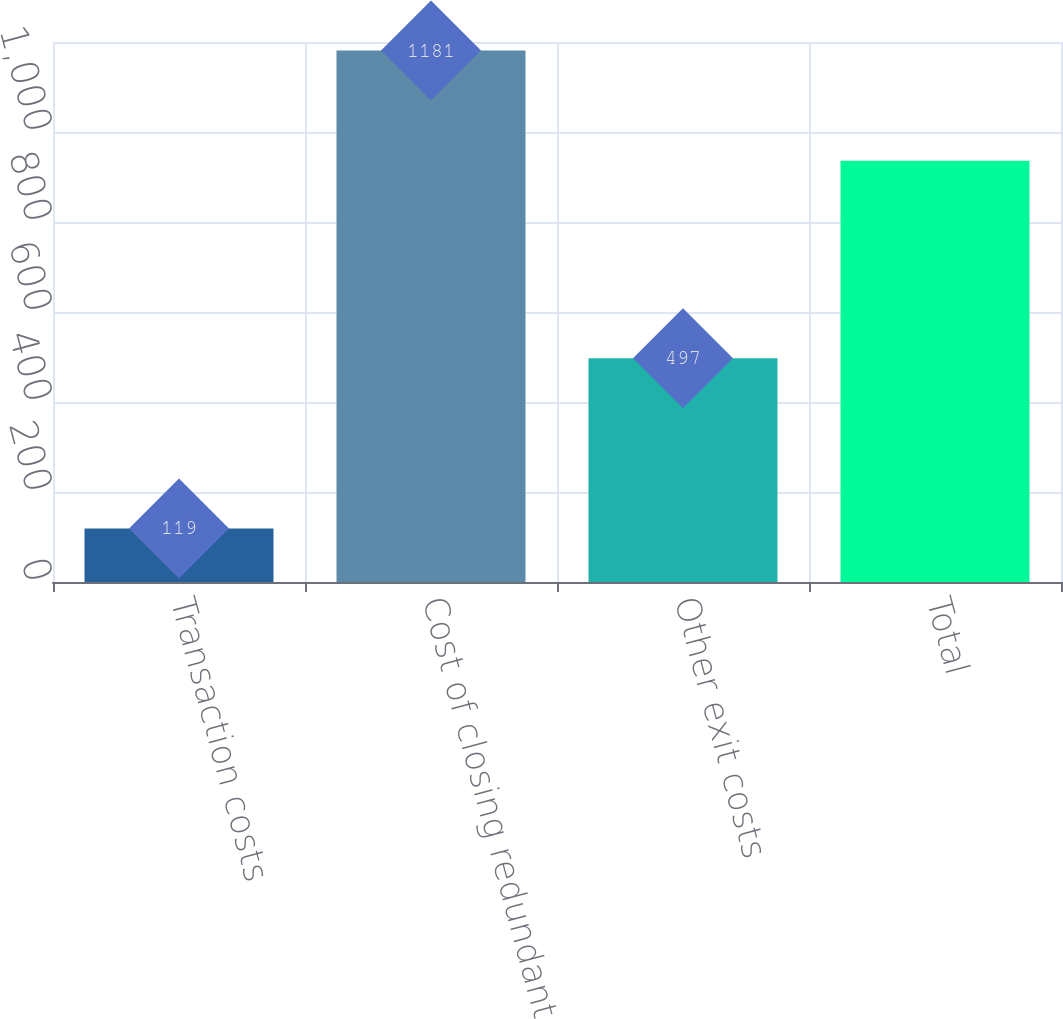Convert chart to OTSL. <chart><loc_0><loc_0><loc_500><loc_500><bar_chart><fcel>Transaction costs<fcel>Cost of closing redundant<fcel>Other exit costs<fcel>Total<nl><fcel>119<fcel>1181<fcel>497<fcel>936<nl></chart> 